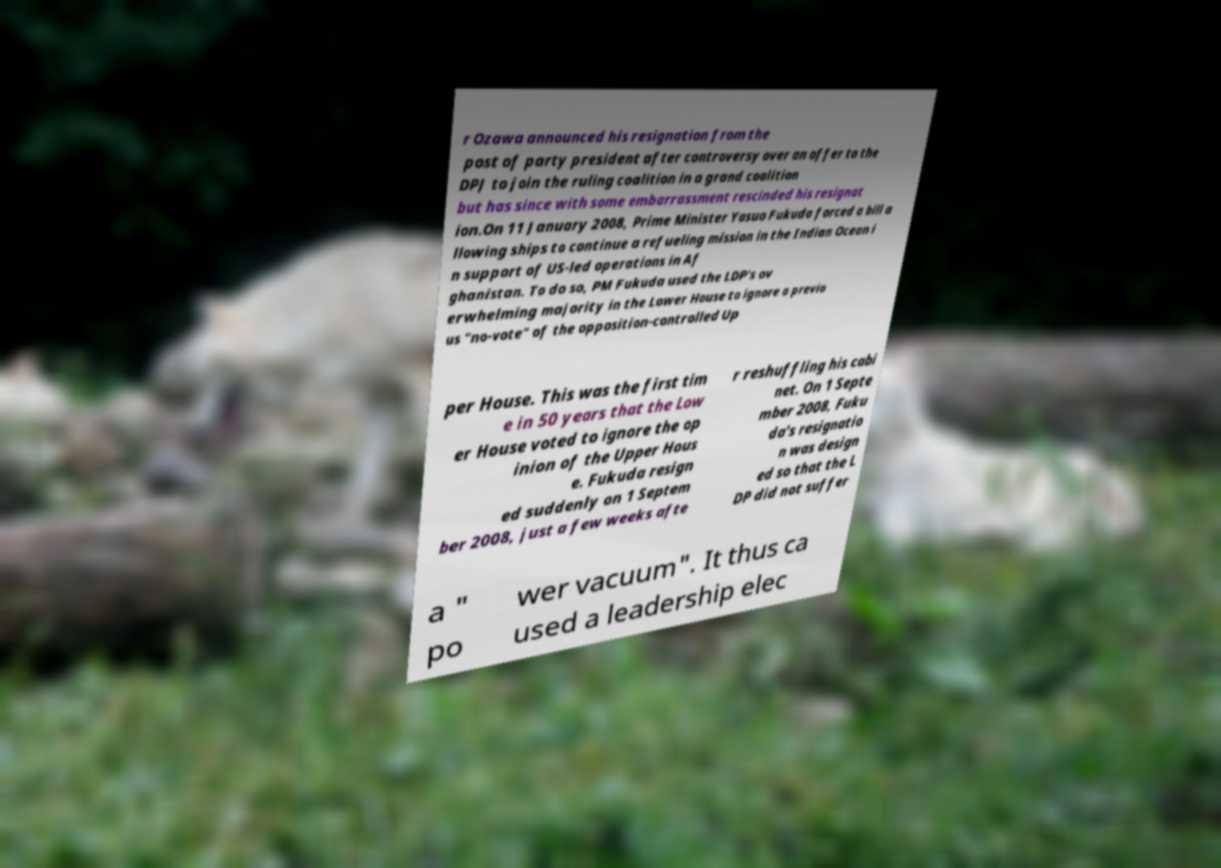Please identify and transcribe the text found in this image. r Ozawa announced his resignation from the post of party president after controversy over an offer to the DPJ to join the ruling coalition in a grand coalition but has since with some embarrassment rescinded his resignat ion.On 11 January 2008, Prime Minister Yasuo Fukuda forced a bill a llowing ships to continue a refueling mission in the Indian Ocean i n support of US-led operations in Af ghanistan. To do so, PM Fukuda used the LDP's ov erwhelming majority in the Lower House to ignore a previo us "no-vote" of the opposition-controlled Up per House. This was the first tim e in 50 years that the Low er House voted to ignore the op inion of the Upper Hous e. Fukuda resign ed suddenly on 1 Septem ber 2008, just a few weeks afte r reshuffling his cabi net. On 1 Septe mber 2008, Fuku da's resignatio n was design ed so that the L DP did not suffer a " po wer vacuum". It thus ca used a leadership elec 